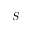<formula> <loc_0><loc_0><loc_500><loc_500>S</formula> 